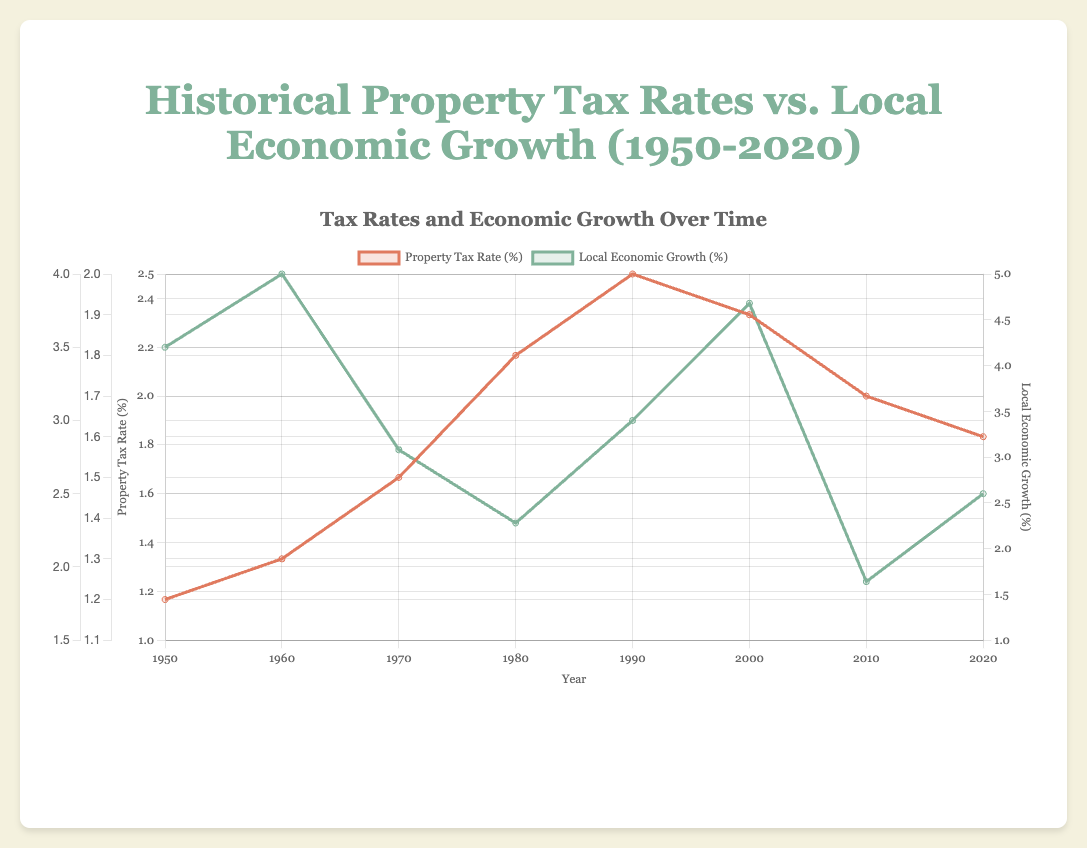How has the property tax rate changed from 1950 to 2020? To determine this, we look at the property tax rate for the years 1950 and 2020 directly from the plot. In 1950, the rate was 1.2%, and in 2020, it was 1.6%. We see an increase of 0.4%.
Answer: Increased by 0.4% What year had the highest local economic growth? By observing the plot for local economic growth, we see that the year with the highest value is 1960 with a growth rate of 4.0%.
Answer: 1960 Compare the property tax rate in 1980 to 2010. Which year had a higher rate? Checking the plot, the property tax rate in 1980 was 1.8%, and in 2010, it was 1.7%. Therefore, the rate was higher in 1980.
Answer: 1980 What was the combined local economic growth for the years 1970 and 2000? From the plot, local economic growth in 1970 was 2.8% and in 2000, it was 3.8%. Adding them together, 2.8% + 3.8% = 6.6%.
Answer: 6.6% What year showed the largest decrease in property tax rate from the previous decade? We compare the property tax rates across the decades. The largest decrease was from 2000 to 2010, dropping from 1.9% to 1.7%, a decrease of 0.2%.
Answer: 2010 In which decade was the local economic growth the lowest? By observing decade-to-decade changes, the local economic growth was lowest in 2010 with a 1.9% growth rate.
Answer: 2010 How has local economic growth changed compared to property tax rate from 2000 to 2010? The property tax rate decreased from 1.9% to 1.7%, and local economic growth also decreased from 3.8% to 1.9%. Both rates decreased during this period.
Answer: Both decreased What is the average property tax rate for the years listed in the data? The property tax rates are: 1.2%, 1.3%, 1.5%, 1.8%, 2.0%, 1.9%, 1.7%, 1.6%. Summing these = 12 and dividing by 8 gives an average of 1.5%.
Answer: 1.5% What visual color represents local economic growth in the plot? By looking at the legend, local economic growth is represented by a green color.
Answer: Green 